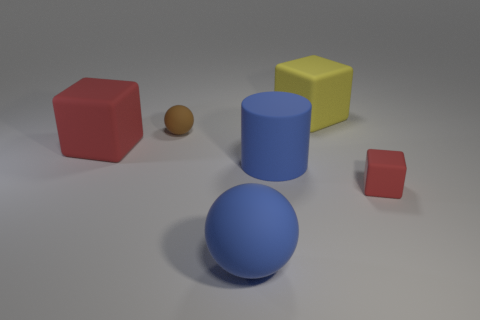Are there any other small matte balls of the same color as the tiny ball? no 